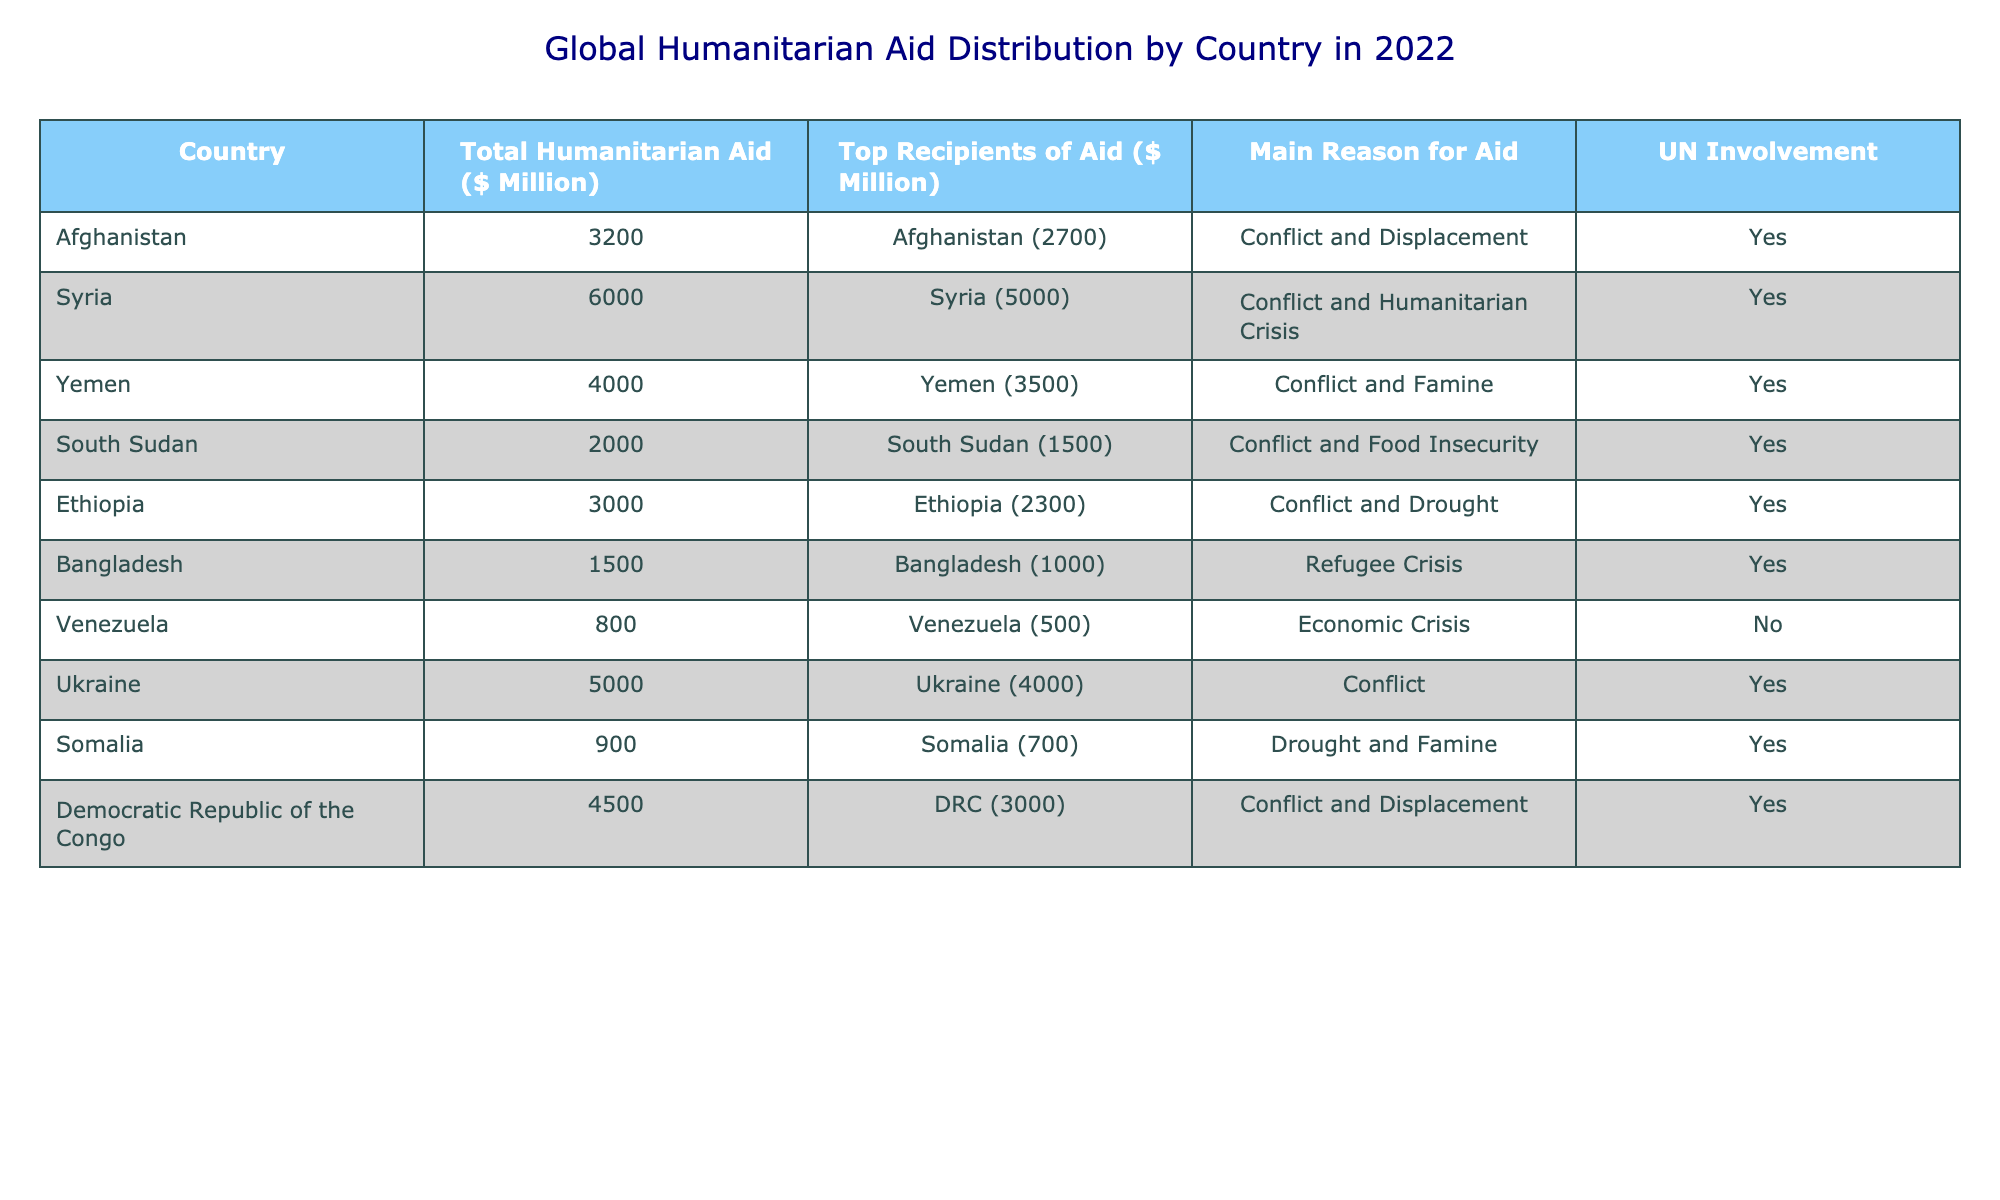What is the total humanitarian aid provided to Afghanistan in 2022? The table shows that the total humanitarian aid for Afghanistan is $3200 million.
Answer: 3200 million What are the main reasons for providing humanitarian aid to Syria? Based on the table, the main reasons for providing humanitarian aid to Syria are conflict and humanitarian crisis.
Answer: Conflict and humanitarian crisis Which country received the least amount of humanitarian aid in 2022? According to the table, Venezuela received the least amount of humanitarian aid, which is $800 million.
Answer: Venezuela What is the total humanitarian aid received by the top three countries (Syria, Yemen, Afghanistan)? To find this, we sum the total humanitarian aid for the top three countries: Syria (6000) + Yemen (4000) + Afghanistan (3200) = 13200 million.
Answer: 13200 million How many countries in the table have UN involvement in their humanitarian aid? The table lists 10 entries, and a review shows that all listed countries except Venezuela have UN involvement. So, 9 countries have UN involvement.
Answer: 9 countries What is the average humanitarian aid amount provided to the countries involved in conflict? First, identify the countries involved in conflict from the table (Afghanistan, Syria, Yemen, South Sudan, Ethiopia, Ukraine, Democratic Republic of the Congo). Their total aid is (3200 + 6000 + 4000 + 2000 + 3000 + 5000 + 4500) = 28700 million. There are 7 countries, so the average is 28700/7 = 4100 million.
Answer: 4100 million Is it true that all countries listed received aid for reasons related to conflict? Upon examining the table, it shows that Bangladesh received aid for a refugee crisis and Venezuela for an economic crisis. Therefore, it is false that all countries received aid for conflict-related reasons.
Answer: No What was the total humanitarian aid provided to Somalia and South Sudan? To calculate this, we add the amounts for Somalia ($900 million) and South Sudan ($2000 million), which equals 2900 million.
Answer: 2900 million Which country with the highest amount of aid has a reason of famine listed? According to the table, Yemen received the highest amount of aid specifically associated with famine, which is $4000 million.
Answer: Yemen 